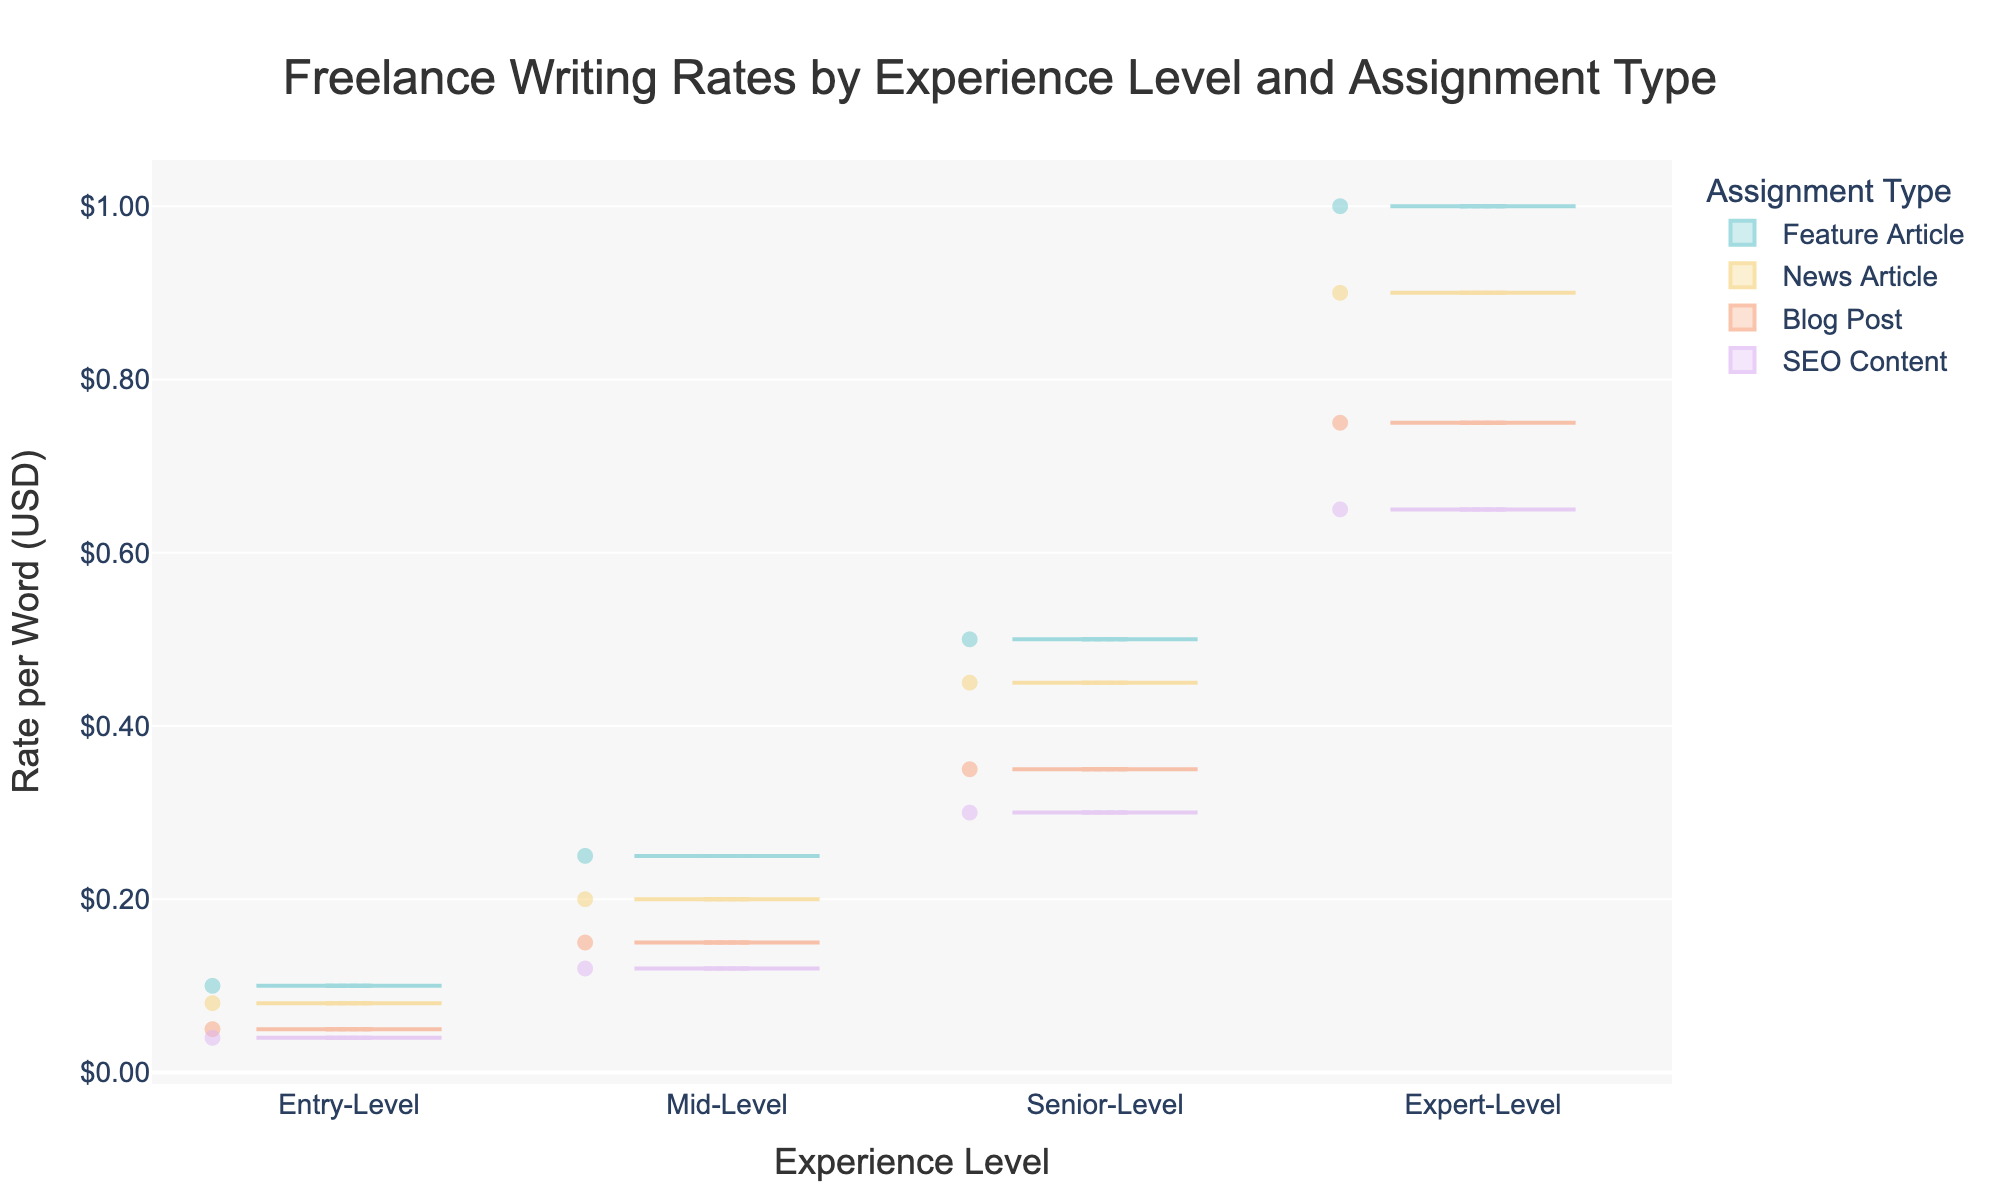What's the title of the figure? The title of the figure is displayed above the chart area in a large font size. It provides an overview of what the chart is about.
Answer: Freelance Writing Rates by Experience Level and Assignment Type What are the axis titles? The axis titles can be found along the horizontal and vertical axes and provide context to what each axis represents. The horizontal axis represents the experience level, while the vertical axis represents the rate per word in USD.
Answer: Experience Level (x-axis) and Rate per Word (USD) (y-axis) Which assignment type has the highest median rate for Expert-Level freelancers? To find the highest median rate for Expert-Level, look for the violin plot with the highest median line within the Expert-Level category. Each violin plot for Expert-Level showcases different assignment types.
Answer: Feature Article Is there any overlap between the rates of Entry-Level and Mid-Level freelancers for the same assignment type? To determine overlap, compare the range of the violin plots for Entry-Level and Mid-Level freelancers. Overlapping regions indicate shared rate ranges.
Answer: Yes Which experience level shows the most variability in rates for News Articles? Variability is shown in a violin plot by the spread of the plot. Look at the News Article plots across all experience levels and compare their widths.
Answer: Expert-Level How does the median rate for SEO Content compare between Entry-Level and Senior-Level? Compare the median lines (bold horizontal lines) of the SEO Content violins for both Entry-Level and Senior-Level. This will show the difference or similarity.
Answer: Senior-Level is higher What's the lowest rate observed for Feature Articles among Entry-Level freelancers? The lowest rate in a violin plot can be identified by the bottommost point of the plot within the Entry-Level category for Feature Articles.
Answer: 0.10 USD For Blog Posts, which experience level has the smallest interquartile range? The interquartile range in a violin plot is indicated by the box within the plot. Compare the sizes of these boxes for Blog Posts across all experience levels.
Answer: Entry-Level Do Mid-Level freelancers charge more on average for Feature Articles than Senior-Level freelancers? Compare the average rates, often shown by the mean line within the violin plots, for Feature Articles between Mid-Level and Senior-Level freelancers.
Answer: No Which experience level shows the least average rate increase for SEO Content compared to the previous level? Calculate the average rate for SEO Content at each level and compare the increment between consecutive levels. The smallest difference indicates the least rate increase.
Answer: Entry-Level to Mid-Level 